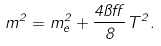<formula> <loc_0><loc_0><loc_500><loc_500>m ^ { 2 } = m _ { e } ^ { 2 } + \frac { 4 \pi \alpha } { 8 } T ^ { 2 } .</formula> 